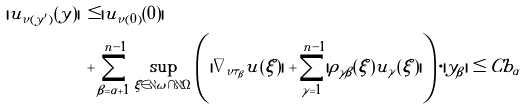<formula> <loc_0><loc_0><loc_500><loc_500>| u _ { \tilde { \nu } ( y ^ { \prime } ) } ( y ) | \, & \leq | u _ { \tilde { \nu } ( 0 ) } ( 0 ) | \\ & + \sum _ { \beta = \alpha + 1 } ^ { n - 1 } \sup _ { \xi \in \partial \omega \cap \partial \Omega } \left ( | \nabla _ { \tilde { \nu } \tau _ { \beta } } u ( \xi ) | + \sum _ { \gamma = 1 } ^ { n - 1 } | \rho _ { \gamma \beta } ( \xi ) u _ { \gamma } ( \xi ) | \right ) \cdot | y _ { \beta } | \leq C b _ { \alpha }</formula> 